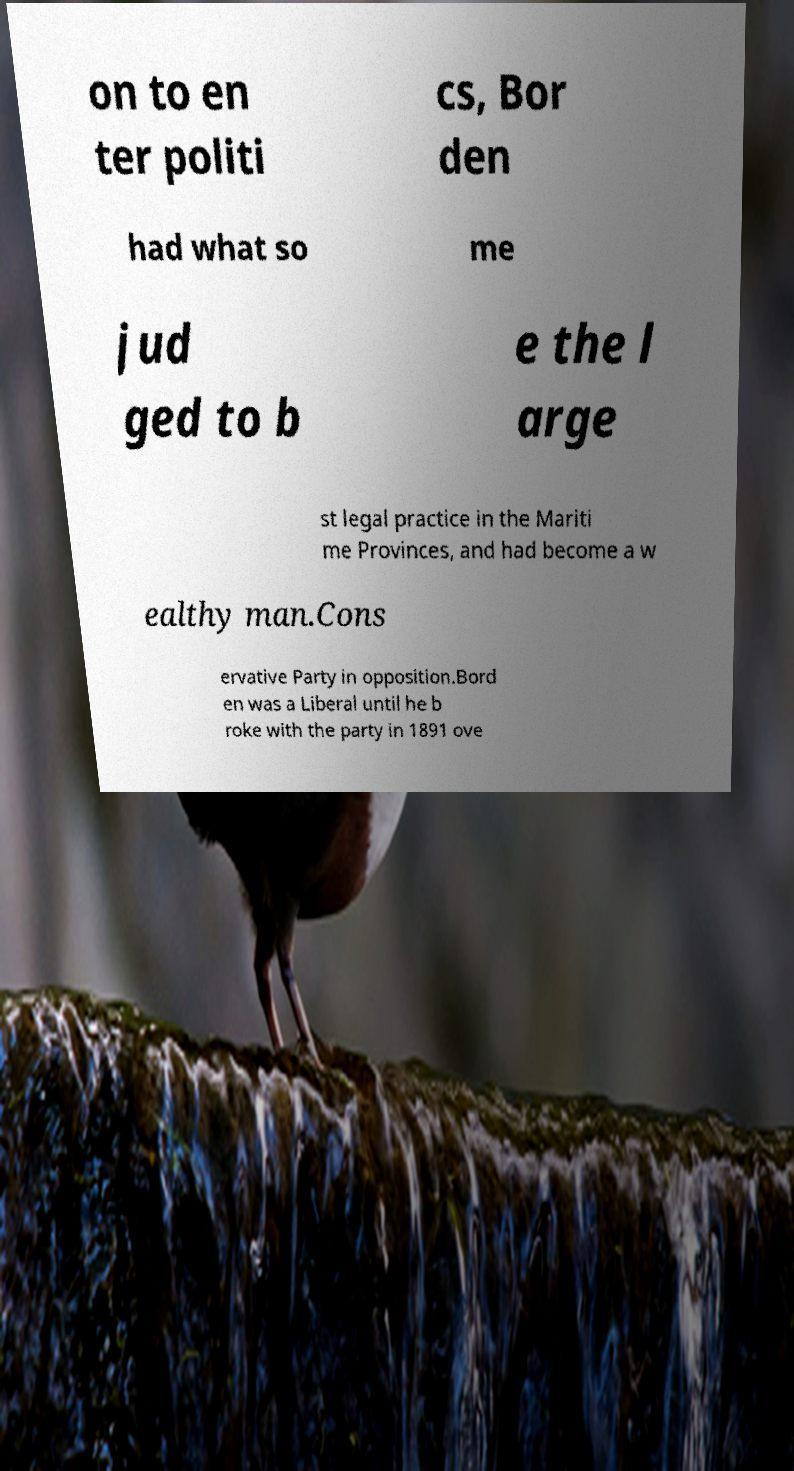Please identify and transcribe the text found in this image. on to en ter politi cs, Bor den had what so me jud ged to b e the l arge st legal practice in the Mariti me Provinces, and had become a w ealthy man.Cons ervative Party in opposition.Bord en was a Liberal until he b roke with the party in 1891 ove 